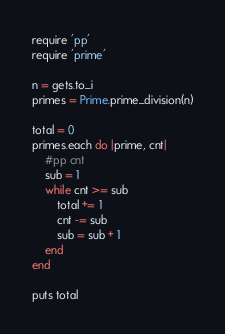<code> <loc_0><loc_0><loc_500><loc_500><_Ruby_>require 'pp'
require 'prime'

n = gets.to_i
primes = Prime.prime_division(n)

total = 0
primes.each do |prime, cnt|
    #pp cnt
    sub = 1
    while cnt >= sub
        total += 1
        cnt -= sub
        sub = sub + 1
    end
end

puts total
</code> 